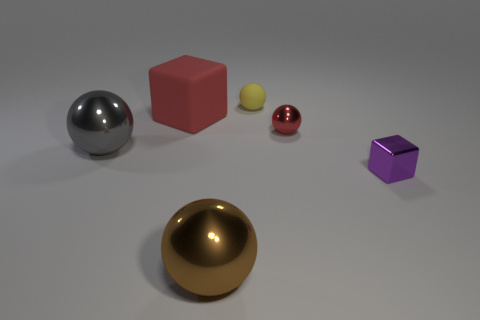Subtract 1 spheres. How many spheres are left? 3 Add 3 big brown shiny cylinders. How many objects exist? 9 Subtract 1 brown spheres. How many objects are left? 5 Subtract all cubes. How many objects are left? 4 Subtract all yellow rubber spheres. Subtract all metal balls. How many objects are left? 2 Add 3 big things. How many big things are left? 6 Add 4 green matte blocks. How many green matte blocks exist? 4 